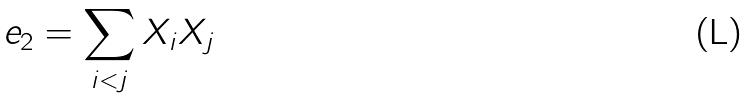<formula> <loc_0><loc_0><loc_500><loc_500>e _ { 2 } = \sum _ { i < j } X _ { i } X _ { j }</formula> 